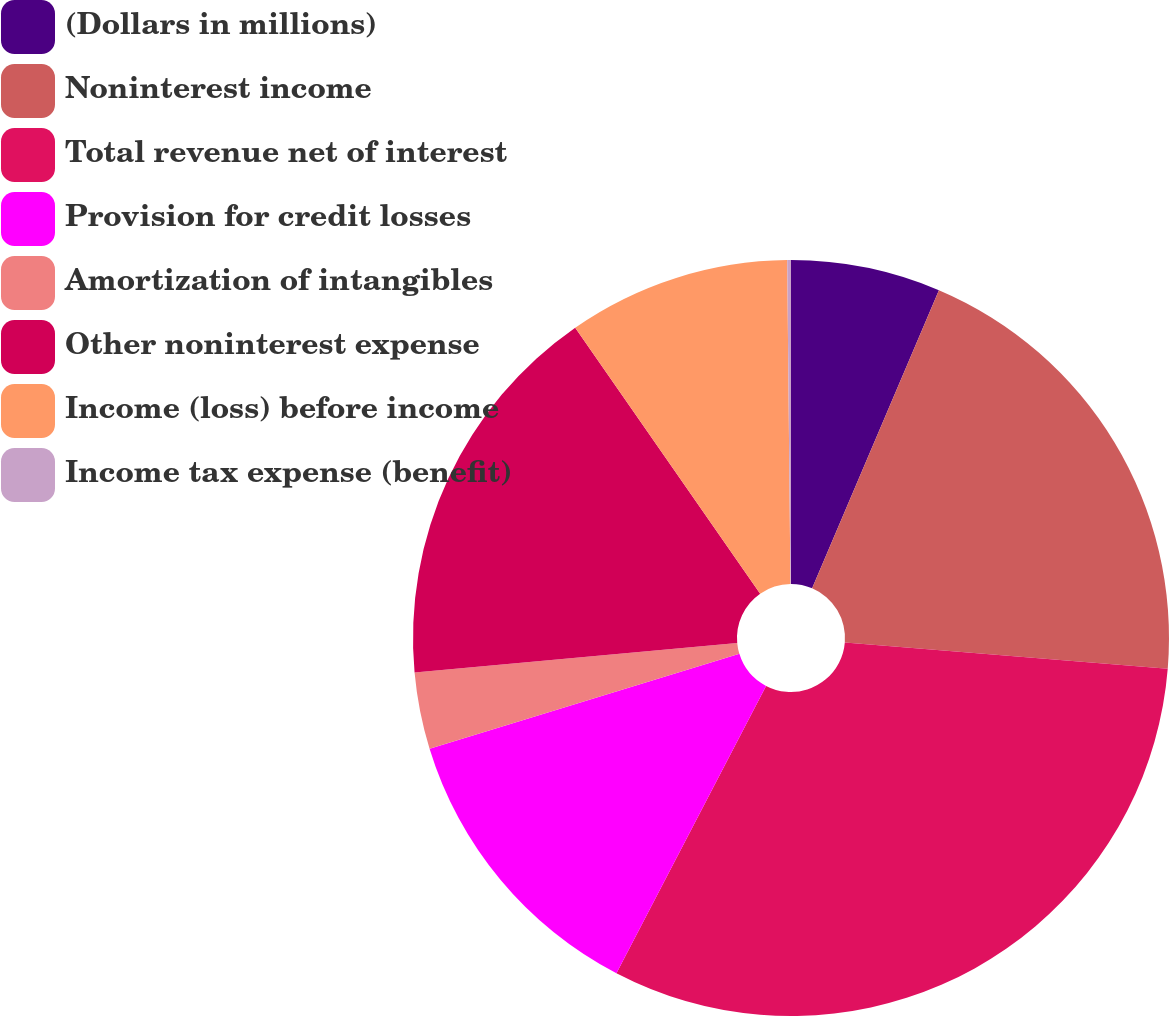Convert chart. <chart><loc_0><loc_0><loc_500><loc_500><pie_chart><fcel>(Dollars in millions)<fcel>Noninterest income<fcel>Total revenue net of interest<fcel>Provision for credit losses<fcel>Amortization of intangibles<fcel>Other noninterest expense<fcel>Income (loss) before income<fcel>Income tax expense (benefit)<nl><fcel>6.4%<fcel>19.9%<fcel>31.34%<fcel>12.63%<fcel>3.28%<fcel>16.78%<fcel>9.51%<fcel>0.16%<nl></chart> 